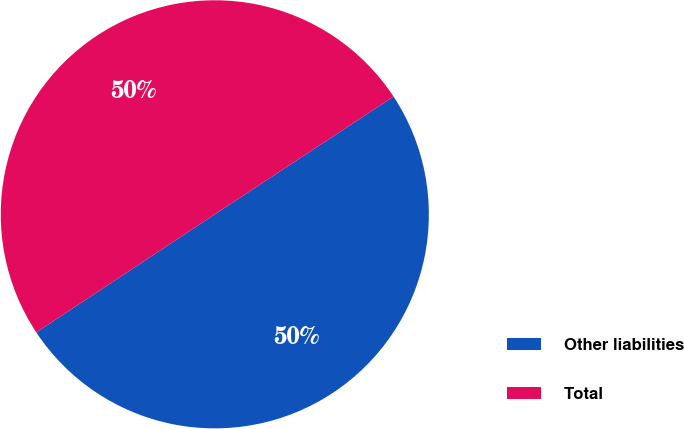Convert chart to OTSL. <chart><loc_0><loc_0><loc_500><loc_500><pie_chart><fcel>Other liabilities<fcel>Total<nl><fcel>49.97%<fcel>50.03%<nl></chart> 